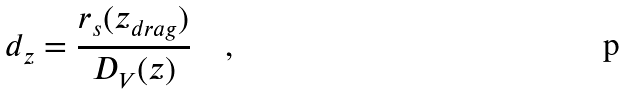Convert formula to latex. <formula><loc_0><loc_0><loc_500><loc_500>d _ { z } = \frac { r _ { s } ( z _ { d r a g } ) } { D _ { V } ( z ) } \quad ,</formula> 